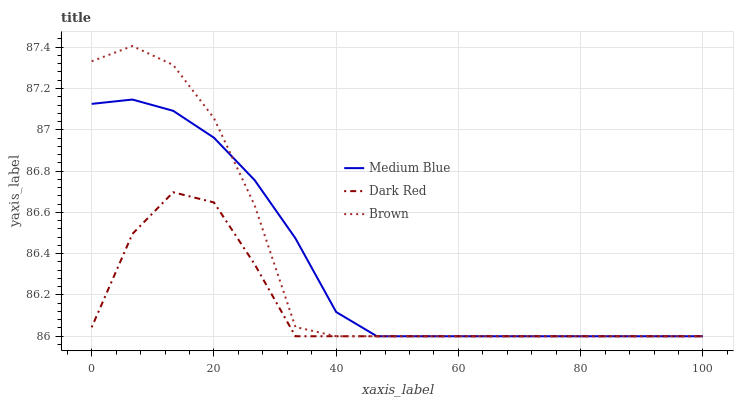Does Dark Red have the minimum area under the curve?
Answer yes or no. Yes. Does Brown have the maximum area under the curve?
Answer yes or no. Yes. Does Medium Blue have the minimum area under the curve?
Answer yes or no. No. Does Medium Blue have the maximum area under the curve?
Answer yes or no. No. Is Medium Blue the smoothest?
Answer yes or no. Yes. Is Brown the roughest?
Answer yes or no. Yes. Is Brown the smoothest?
Answer yes or no. No. Is Medium Blue the roughest?
Answer yes or no. No. Does Dark Red have the lowest value?
Answer yes or no. Yes. Does Brown have the highest value?
Answer yes or no. Yes. Does Medium Blue have the highest value?
Answer yes or no. No. Does Dark Red intersect Brown?
Answer yes or no. Yes. Is Dark Red less than Brown?
Answer yes or no. No. Is Dark Red greater than Brown?
Answer yes or no. No. 